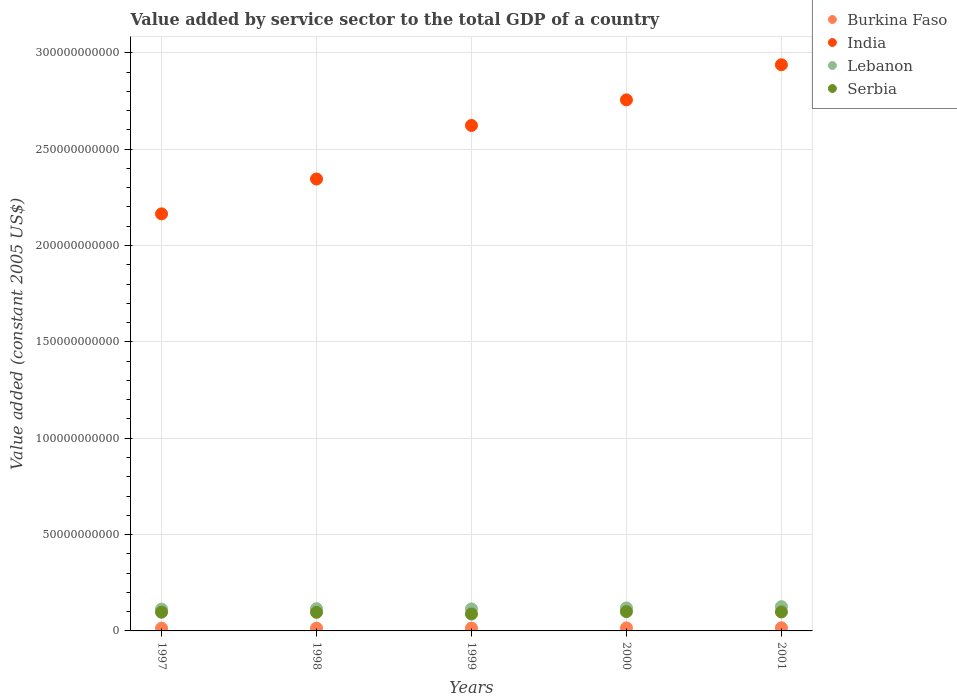How many different coloured dotlines are there?
Offer a very short reply. 4. What is the value added by service sector in Serbia in 1997?
Offer a terse response. 9.73e+09. Across all years, what is the maximum value added by service sector in Burkina Faso?
Ensure brevity in your answer.  1.62e+09. Across all years, what is the minimum value added by service sector in Burkina Faso?
Give a very brief answer. 1.40e+09. In which year was the value added by service sector in Lebanon minimum?
Your answer should be compact. 1997. What is the total value added by service sector in India in the graph?
Make the answer very short. 1.28e+12. What is the difference between the value added by service sector in India in 1999 and that in 2001?
Keep it short and to the point. -3.15e+1. What is the difference between the value added by service sector in Lebanon in 1999 and the value added by service sector in India in 2001?
Ensure brevity in your answer.  -2.82e+11. What is the average value added by service sector in India per year?
Your response must be concise. 2.57e+11. In the year 1999, what is the difference between the value added by service sector in Burkina Faso and value added by service sector in India?
Make the answer very short. -2.61e+11. What is the ratio of the value added by service sector in India in 1998 to that in 2001?
Make the answer very short. 0.8. Is the value added by service sector in Burkina Faso in 2000 less than that in 2001?
Offer a very short reply. Yes. Is the difference between the value added by service sector in Burkina Faso in 1998 and 1999 greater than the difference between the value added by service sector in India in 1998 and 1999?
Make the answer very short. Yes. What is the difference between the highest and the second highest value added by service sector in Burkina Faso?
Your response must be concise. 5.86e+07. What is the difference between the highest and the lowest value added by service sector in India?
Ensure brevity in your answer.  7.74e+1. In how many years, is the value added by service sector in India greater than the average value added by service sector in India taken over all years?
Ensure brevity in your answer.  3. Is the sum of the value added by service sector in India in 1997 and 2000 greater than the maximum value added by service sector in Lebanon across all years?
Keep it short and to the point. Yes. Is it the case that in every year, the sum of the value added by service sector in Burkina Faso and value added by service sector in Lebanon  is greater than the value added by service sector in India?
Your response must be concise. No. Does the value added by service sector in Burkina Faso monotonically increase over the years?
Provide a succinct answer. No. Is the value added by service sector in Burkina Faso strictly greater than the value added by service sector in Serbia over the years?
Offer a very short reply. No. Is the value added by service sector in Burkina Faso strictly less than the value added by service sector in India over the years?
Your response must be concise. Yes. Are the values on the major ticks of Y-axis written in scientific E-notation?
Make the answer very short. No. Does the graph contain any zero values?
Make the answer very short. No. How many legend labels are there?
Offer a terse response. 4. How are the legend labels stacked?
Your answer should be compact. Vertical. What is the title of the graph?
Provide a short and direct response. Value added by service sector to the total GDP of a country. What is the label or title of the X-axis?
Ensure brevity in your answer.  Years. What is the label or title of the Y-axis?
Your response must be concise. Value added (constant 2005 US$). What is the Value added (constant 2005 US$) in Burkina Faso in 1997?
Ensure brevity in your answer.  1.40e+09. What is the Value added (constant 2005 US$) of India in 1997?
Offer a terse response. 2.16e+11. What is the Value added (constant 2005 US$) of Lebanon in 1997?
Make the answer very short. 1.13e+1. What is the Value added (constant 2005 US$) in Serbia in 1997?
Make the answer very short. 9.73e+09. What is the Value added (constant 2005 US$) in Burkina Faso in 1998?
Offer a very short reply. 1.44e+09. What is the Value added (constant 2005 US$) in India in 1998?
Provide a succinct answer. 2.35e+11. What is the Value added (constant 2005 US$) of Lebanon in 1998?
Make the answer very short. 1.15e+1. What is the Value added (constant 2005 US$) of Serbia in 1998?
Provide a succinct answer. 9.64e+09. What is the Value added (constant 2005 US$) in Burkina Faso in 1999?
Provide a short and direct response. 1.44e+09. What is the Value added (constant 2005 US$) in India in 1999?
Make the answer very short. 2.62e+11. What is the Value added (constant 2005 US$) of Lebanon in 1999?
Your answer should be very brief. 1.14e+1. What is the Value added (constant 2005 US$) of Serbia in 1999?
Provide a short and direct response. 8.80e+09. What is the Value added (constant 2005 US$) of Burkina Faso in 2000?
Ensure brevity in your answer.  1.56e+09. What is the Value added (constant 2005 US$) in India in 2000?
Your response must be concise. 2.76e+11. What is the Value added (constant 2005 US$) in Lebanon in 2000?
Ensure brevity in your answer.  1.19e+1. What is the Value added (constant 2005 US$) of Serbia in 2000?
Ensure brevity in your answer.  1.00e+1. What is the Value added (constant 2005 US$) of Burkina Faso in 2001?
Make the answer very short. 1.62e+09. What is the Value added (constant 2005 US$) in India in 2001?
Your response must be concise. 2.94e+11. What is the Value added (constant 2005 US$) in Lebanon in 2001?
Offer a terse response. 1.26e+1. What is the Value added (constant 2005 US$) in Serbia in 2001?
Provide a short and direct response. 9.84e+09. Across all years, what is the maximum Value added (constant 2005 US$) of Burkina Faso?
Your answer should be compact. 1.62e+09. Across all years, what is the maximum Value added (constant 2005 US$) in India?
Provide a short and direct response. 2.94e+11. Across all years, what is the maximum Value added (constant 2005 US$) in Lebanon?
Make the answer very short. 1.26e+1. Across all years, what is the maximum Value added (constant 2005 US$) of Serbia?
Ensure brevity in your answer.  1.00e+1. Across all years, what is the minimum Value added (constant 2005 US$) of Burkina Faso?
Offer a very short reply. 1.40e+09. Across all years, what is the minimum Value added (constant 2005 US$) in India?
Keep it short and to the point. 2.16e+11. Across all years, what is the minimum Value added (constant 2005 US$) in Lebanon?
Make the answer very short. 1.13e+1. Across all years, what is the minimum Value added (constant 2005 US$) in Serbia?
Provide a succinct answer. 8.80e+09. What is the total Value added (constant 2005 US$) of Burkina Faso in the graph?
Provide a succinct answer. 7.47e+09. What is the total Value added (constant 2005 US$) in India in the graph?
Provide a succinct answer. 1.28e+12. What is the total Value added (constant 2005 US$) of Lebanon in the graph?
Make the answer very short. 5.88e+1. What is the total Value added (constant 2005 US$) of Serbia in the graph?
Provide a succinct answer. 4.80e+1. What is the difference between the Value added (constant 2005 US$) in Burkina Faso in 1997 and that in 1998?
Ensure brevity in your answer.  -4.05e+07. What is the difference between the Value added (constant 2005 US$) in India in 1997 and that in 1998?
Provide a succinct answer. -1.81e+1. What is the difference between the Value added (constant 2005 US$) in Lebanon in 1997 and that in 1998?
Ensure brevity in your answer.  -1.89e+08. What is the difference between the Value added (constant 2005 US$) of Serbia in 1997 and that in 1998?
Your response must be concise. 8.61e+07. What is the difference between the Value added (constant 2005 US$) in Burkina Faso in 1997 and that in 1999?
Make the answer very short. -3.97e+07. What is the difference between the Value added (constant 2005 US$) in India in 1997 and that in 1999?
Provide a succinct answer. -4.59e+1. What is the difference between the Value added (constant 2005 US$) in Lebanon in 1997 and that in 1999?
Make the answer very short. -1.01e+08. What is the difference between the Value added (constant 2005 US$) of Serbia in 1997 and that in 1999?
Your response must be concise. 9.27e+08. What is the difference between the Value added (constant 2005 US$) of Burkina Faso in 1997 and that in 2000?
Ensure brevity in your answer.  -1.62e+08. What is the difference between the Value added (constant 2005 US$) of India in 1997 and that in 2000?
Your response must be concise. -5.92e+1. What is the difference between the Value added (constant 2005 US$) of Lebanon in 1997 and that in 2000?
Give a very brief answer. -6.04e+08. What is the difference between the Value added (constant 2005 US$) in Serbia in 1997 and that in 2000?
Your answer should be very brief. -2.72e+08. What is the difference between the Value added (constant 2005 US$) in Burkina Faso in 1997 and that in 2001?
Your response must be concise. -2.21e+08. What is the difference between the Value added (constant 2005 US$) in India in 1997 and that in 2001?
Give a very brief answer. -7.74e+1. What is the difference between the Value added (constant 2005 US$) of Lebanon in 1997 and that in 2001?
Your answer should be compact. -1.26e+09. What is the difference between the Value added (constant 2005 US$) in Serbia in 1997 and that in 2001?
Your answer should be compact. -1.15e+08. What is the difference between the Value added (constant 2005 US$) in Burkina Faso in 1998 and that in 1999?
Your response must be concise. 8.60e+05. What is the difference between the Value added (constant 2005 US$) of India in 1998 and that in 1999?
Your answer should be compact. -2.78e+1. What is the difference between the Value added (constant 2005 US$) in Lebanon in 1998 and that in 1999?
Offer a very short reply. 8.77e+07. What is the difference between the Value added (constant 2005 US$) in Serbia in 1998 and that in 1999?
Your answer should be compact. 8.41e+08. What is the difference between the Value added (constant 2005 US$) of Burkina Faso in 1998 and that in 2000?
Provide a short and direct response. -1.22e+08. What is the difference between the Value added (constant 2005 US$) in India in 1998 and that in 2000?
Offer a very short reply. -4.11e+1. What is the difference between the Value added (constant 2005 US$) of Lebanon in 1998 and that in 2000?
Your answer should be very brief. -4.15e+08. What is the difference between the Value added (constant 2005 US$) of Serbia in 1998 and that in 2000?
Your response must be concise. -3.58e+08. What is the difference between the Value added (constant 2005 US$) of Burkina Faso in 1998 and that in 2001?
Provide a succinct answer. -1.80e+08. What is the difference between the Value added (constant 2005 US$) of India in 1998 and that in 2001?
Your answer should be compact. -5.93e+1. What is the difference between the Value added (constant 2005 US$) in Lebanon in 1998 and that in 2001?
Offer a very short reply. -1.07e+09. What is the difference between the Value added (constant 2005 US$) in Serbia in 1998 and that in 2001?
Give a very brief answer. -2.01e+08. What is the difference between the Value added (constant 2005 US$) in Burkina Faso in 1999 and that in 2000?
Offer a terse response. -1.23e+08. What is the difference between the Value added (constant 2005 US$) in India in 1999 and that in 2000?
Ensure brevity in your answer.  -1.33e+1. What is the difference between the Value added (constant 2005 US$) of Lebanon in 1999 and that in 2000?
Ensure brevity in your answer.  -5.03e+08. What is the difference between the Value added (constant 2005 US$) of Serbia in 1999 and that in 2000?
Ensure brevity in your answer.  -1.20e+09. What is the difference between the Value added (constant 2005 US$) in Burkina Faso in 1999 and that in 2001?
Keep it short and to the point. -1.81e+08. What is the difference between the Value added (constant 2005 US$) in India in 1999 and that in 2001?
Provide a short and direct response. -3.15e+1. What is the difference between the Value added (constant 2005 US$) in Lebanon in 1999 and that in 2001?
Offer a terse response. -1.16e+09. What is the difference between the Value added (constant 2005 US$) of Serbia in 1999 and that in 2001?
Ensure brevity in your answer.  -1.04e+09. What is the difference between the Value added (constant 2005 US$) in Burkina Faso in 2000 and that in 2001?
Keep it short and to the point. -5.86e+07. What is the difference between the Value added (constant 2005 US$) of India in 2000 and that in 2001?
Offer a terse response. -1.82e+1. What is the difference between the Value added (constant 2005 US$) in Lebanon in 2000 and that in 2001?
Give a very brief answer. -6.55e+08. What is the difference between the Value added (constant 2005 US$) in Serbia in 2000 and that in 2001?
Ensure brevity in your answer.  1.57e+08. What is the difference between the Value added (constant 2005 US$) in Burkina Faso in 1997 and the Value added (constant 2005 US$) in India in 1998?
Keep it short and to the point. -2.33e+11. What is the difference between the Value added (constant 2005 US$) of Burkina Faso in 1997 and the Value added (constant 2005 US$) of Lebanon in 1998?
Provide a succinct answer. -1.01e+1. What is the difference between the Value added (constant 2005 US$) in Burkina Faso in 1997 and the Value added (constant 2005 US$) in Serbia in 1998?
Make the answer very short. -8.24e+09. What is the difference between the Value added (constant 2005 US$) in India in 1997 and the Value added (constant 2005 US$) in Lebanon in 1998?
Make the answer very short. 2.05e+11. What is the difference between the Value added (constant 2005 US$) in India in 1997 and the Value added (constant 2005 US$) in Serbia in 1998?
Offer a very short reply. 2.07e+11. What is the difference between the Value added (constant 2005 US$) of Lebanon in 1997 and the Value added (constant 2005 US$) of Serbia in 1998?
Keep it short and to the point. 1.70e+09. What is the difference between the Value added (constant 2005 US$) of Burkina Faso in 1997 and the Value added (constant 2005 US$) of India in 1999?
Keep it short and to the point. -2.61e+11. What is the difference between the Value added (constant 2005 US$) in Burkina Faso in 1997 and the Value added (constant 2005 US$) in Lebanon in 1999?
Provide a short and direct response. -1.00e+1. What is the difference between the Value added (constant 2005 US$) in Burkina Faso in 1997 and the Value added (constant 2005 US$) in Serbia in 1999?
Provide a short and direct response. -7.40e+09. What is the difference between the Value added (constant 2005 US$) in India in 1997 and the Value added (constant 2005 US$) in Lebanon in 1999?
Provide a short and direct response. 2.05e+11. What is the difference between the Value added (constant 2005 US$) in India in 1997 and the Value added (constant 2005 US$) in Serbia in 1999?
Offer a terse response. 2.08e+11. What is the difference between the Value added (constant 2005 US$) of Lebanon in 1997 and the Value added (constant 2005 US$) of Serbia in 1999?
Make the answer very short. 2.54e+09. What is the difference between the Value added (constant 2005 US$) in Burkina Faso in 1997 and the Value added (constant 2005 US$) in India in 2000?
Offer a terse response. -2.74e+11. What is the difference between the Value added (constant 2005 US$) of Burkina Faso in 1997 and the Value added (constant 2005 US$) of Lebanon in 2000?
Offer a terse response. -1.05e+1. What is the difference between the Value added (constant 2005 US$) of Burkina Faso in 1997 and the Value added (constant 2005 US$) of Serbia in 2000?
Provide a short and direct response. -8.60e+09. What is the difference between the Value added (constant 2005 US$) in India in 1997 and the Value added (constant 2005 US$) in Lebanon in 2000?
Provide a short and direct response. 2.04e+11. What is the difference between the Value added (constant 2005 US$) of India in 1997 and the Value added (constant 2005 US$) of Serbia in 2000?
Your answer should be very brief. 2.06e+11. What is the difference between the Value added (constant 2005 US$) in Lebanon in 1997 and the Value added (constant 2005 US$) in Serbia in 2000?
Make the answer very short. 1.34e+09. What is the difference between the Value added (constant 2005 US$) in Burkina Faso in 1997 and the Value added (constant 2005 US$) in India in 2001?
Give a very brief answer. -2.92e+11. What is the difference between the Value added (constant 2005 US$) in Burkina Faso in 1997 and the Value added (constant 2005 US$) in Lebanon in 2001?
Give a very brief answer. -1.12e+1. What is the difference between the Value added (constant 2005 US$) of Burkina Faso in 1997 and the Value added (constant 2005 US$) of Serbia in 2001?
Give a very brief answer. -8.44e+09. What is the difference between the Value added (constant 2005 US$) of India in 1997 and the Value added (constant 2005 US$) of Lebanon in 2001?
Offer a terse response. 2.04e+11. What is the difference between the Value added (constant 2005 US$) of India in 1997 and the Value added (constant 2005 US$) of Serbia in 2001?
Give a very brief answer. 2.07e+11. What is the difference between the Value added (constant 2005 US$) in Lebanon in 1997 and the Value added (constant 2005 US$) in Serbia in 2001?
Provide a succinct answer. 1.49e+09. What is the difference between the Value added (constant 2005 US$) of Burkina Faso in 1998 and the Value added (constant 2005 US$) of India in 1999?
Your response must be concise. -2.61e+11. What is the difference between the Value added (constant 2005 US$) of Burkina Faso in 1998 and the Value added (constant 2005 US$) of Lebanon in 1999?
Ensure brevity in your answer.  -1.00e+1. What is the difference between the Value added (constant 2005 US$) of Burkina Faso in 1998 and the Value added (constant 2005 US$) of Serbia in 1999?
Give a very brief answer. -7.36e+09. What is the difference between the Value added (constant 2005 US$) of India in 1998 and the Value added (constant 2005 US$) of Lebanon in 1999?
Make the answer very short. 2.23e+11. What is the difference between the Value added (constant 2005 US$) of India in 1998 and the Value added (constant 2005 US$) of Serbia in 1999?
Offer a terse response. 2.26e+11. What is the difference between the Value added (constant 2005 US$) of Lebanon in 1998 and the Value added (constant 2005 US$) of Serbia in 1999?
Provide a succinct answer. 2.73e+09. What is the difference between the Value added (constant 2005 US$) in Burkina Faso in 1998 and the Value added (constant 2005 US$) in India in 2000?
Offer a very short reply. -2.74e+11. What is the difference between the Value added (constant 2005 US$) of Burkina Faso in 1998 and the Value added (constant 2005 US$) of Lebanon in 2000?
Provide a succinct answer. -1.05e+1. What is the difference between the Value added (constant 2005 US$) of Burkina Faso in 1998 and the Value added (constant 2005 US$) of Serbia in 2000?
Your response must be concise. -8.56e+09. What is the difference between the Value added (constant 2005 US$) of India in 1998 and the Value added (constant 2005 US$) of Lebanon in 2000?
Make the answer very short. 2.23e+11. What is the difference between the Value added (constant 2005 US$) of India in 1998 and the Value added (constant 2005 US$) of Serbia in 2000?
Provide a succinct answer. 2.25e+11. What is the difference between the Value added (constant 2005 US$) in Lebanon in 1998 and the Value added (constant 2005 US$) in Serbia in 2000?
Provide a succinct answer. 1.53e+09. What is the difference between the Value added (constant 2005 US$) in Burkina Faso in 1998 and the Value added (constant 2005 US$) in India in 2001?
Make the answer very short. -2.92e+11. What is the difference between the Value added (constant 2005 US$) in Burkina Faso in 1998 and the Value added (constant 2005 US$) in Lebanon in 2001?
Keep it short and to the point. -1.12e+1. What is the difference between the Value added (constant 2005 US$) in Burkina Faso in 1998 and the Value added (constant 2005 US$) in Serbia in 2001?
Your response must be concise. -8.40e+09. What is the difference between the Value added (constant 2005 US$) in India in 1998 and the Value added (constant 2005 US$) in Lebanon in 2001?
Provide a succinct answer. 2.22e+11. What is the difference between the Value added (constant 2005 US$) of India in 1998 and the Value added (constant 2005 US$) of Serbia in 2001?
Provide a short and direct response. 2.25e+11. What is the difference between the Value added (constant 2005 US$) in Lebanon in 1998 and the Value added (constant 2005 US$) in Serbia in 2001?
Offer a terse response. 1.68e+09. What is the difference between the Value added (constant 2005 US$) in Burkina Faso in 1999 and the Value added (constant 2005 US$) in India in 2000?
Offer a very short reply. -2.74e+11. What is the difference between the Value added (constant 2005 US$) in Burkina Faso in 1999 and the Value added (constant 2005 US$) in Lebanon in 2000?
Your answer should be compact. -1.05e+1. What is the difference between the Value added (constant 2005 US$) in Burkina Faso in 1999 and the Value added (constant 2005 US$) in Serbia in 2000?
Keep it short and to the point. -8.56e+09. What is the difference between the Value added (constant 2005 US$) in India in 1999 and the Value added (constant 2005 US$) in Lebanon in 2000?
Your response must be concise. 2.50e+11. What is the difference between the Value added (constant 2005 US$) of India in 1999 and the Value added (constant 2005 US$) of Serbia in 2000?
Give a very brief answer. 2.52e+11. What is the difference between the Value added (constant 2005 US$) of Lebanon in 1999 and the Value added (constant 2005 US$) of Serbia in 2000?
Give a very brief answer. 1.44e+09. What is the difference between the Value added (constant 2005 US$) of Burkina Faso in 1999 and the Value added (constant 2005 US$) of India in 2001?
Offer a very short reply. -2.92e+11. What is the difference between the Value added (constant 2005 US$) of Burkina Faso in 1999 and the Value added (constant 2005 US$) of Lebanon in 2001?
Provide a succinct answer. -1.12e+1. What is the difference between the Value added (constant 2005 US$) in Burkina Faso in 1999 and the Value added (constant 2005 US$) in Serbia in 2001?
Your response must be concise. -8.40e+09. What is the difference between the Value added (constant 2005 US$) of India in 1999 and the Value added (constant 2005 US$) of Lebanon in 2001?
Provide a short and direct response. 2.50e+11. What is the difference between the Value added (constant 2005 US$) in India in 1999 and the Value added (constant 2005 US$) in Serbia in 2001?
Ensure brevity in your answer.  2.52e+11. What is the difference between the Value added (constant 2005 US$) in Lebanon in 1999 and the Value added (constant 2005 US$) in Serbia in 2001?
Provide a succinct answer. 1.60e+09. What is the difference between the Value added (constant 2005 US$) of Burkina Faso in 2000 and the Value added (constant 2005 US$) of India in 2001?
Provide a short and direct response. -2.92e+11. What is the difference between the Value added (constant 2005 US$) in Burkina Faso in 2000 and the Value added (constant 2005 US$) in Lebanon in 2001?
Your answer should be compact. -1.10e+1. What is the difference between the Value added (constant 2005 US$) in Burkina Faso in 2000 and the Value added (constant 2005 US$) in Serbia in 2001?
Your answer should be compact. -8.28e+09. What is the difference between the Value added (constant 2005 US$) of India in 2000 and the Value added (constant 2005 US$) of Lebanon in 2001?
Your response must be concise. 2.63e+11. What is the difference between the Value added (constant 2005 US$) of India in 2000 and the Value added (constant 2005 US$) of Serbia in 2001?
Your answer should be very brief. 2.66e+11. What is the difference between the Value added (constant 2005 US$) in Lebanon in 2000 and the Value added (constant 2005 US$) in Serbia in 2001?
Your answer should be compact. 2.10e+09. What is the average Value added (constant 2005 US$) in Burkina Faso per year?
Give a very brief answer. 1.49e+09. What is the average Value added (constant 2005 US$) in India per year?
Ensure brevity in your answer.  2.57e+11. What is the average Value added (constant 2005 US$) of Lebanon per year?
Give a very brief answer. 1.18e+1. What is the average Value added (constant 2005 US$) in Serbia per year?
Your answer should be compact. 9.60e+09. In the year 1997, what is the difference between the Value added (constant 2005 US$) in Burkina Faso and Value added (constant 2005 US$) in India?
Your response must be concise. -2.15e+11. In the year 1997, what is the difference between the Value added (constant 2005 US$) in Burkina Faso and Value added (constant 2005 US$) in Lebanon?
Make the answer very short. -9.94e+09. In the year 1997, what is the difference between the Value added (constant 2005 US$) of Burkina Faso and Value added (constant 2005 US$) of Serbia?
Keep it short and to the point. -8.33e+09. In the year 1997, what is the difference between the Value added (constant 2005 US$) in India and Value added (constant 2005 US$) in Lebanon?
Your response must be concise. 2.05e+11. In the year 1997, what is the difference between the Value added (constant 2005 US$) of India and Value added (constant 2005 US$) of Serbia?
Make the answer very short. 2.07e+11. In the year 1997, what is the difference between the Value added (constant 2005 US$) of Lebanon and Value added (constant 2005 US$) of Serbia?
Keep it short and to the point. 1.61e+09. In the year 1998, what is the difference between the Value added (constant 2005 US$) of Burkina Faso and Value added (constant 2005 US$) of India?
Give a very brief answer. -2.33e+11. In the year 1998, what is the difference between the Value added (constant 2005 US$) in Burkina Faso and Value added (constant 2005 US$) in Lebanon?
Offer a very short reply. -1.01e+1. In the year 1998, what is the difference between the Value added (constant 2005 US$) in Burkina Faso and Value added (constant 2005 US$) in Serbia?
Provide a short and direct response. -8.20e+09. In the year 1998, what is the difference between the Value added (constant 2005 US$) in India and Value added (constant 2005 US$) in Lebanon?
Ensure brevity in your answer.  2.23e+11. In the year 1998, what is the difference between the Value added (constant 2005 US$) of India and Value added (constant 2005 US$) of Serbia?
Give a very brief answer. 2.25e+11. In the year 1998, what is the difference between the Value added (constant 2005 US$) of Lebanon and Value added (constant 2005 US$) of Serbia?
Make the answer very short. 1.88e+09. In the year 1999, what is the difference between the Value added (constant 2005 US$) in Burkina Faso and Value added (constant 2005 US$) in India?
Ensure brevity in your answer.  -2.61e+11. In the year 1999, what is the difference between the Value added (constant 2005 US$) of Burkina Faso and Value added (constant 2005 US$) of Lebanon?
Your answer should be very brief. -1.00e+1. In the year 1999, what is the difference between the Value added (constant 2005 US$) of Burkina Faso and Value added (constant 2005 US$) of Serbia?
Your response must be concise. -7.36e+09. In the year 1999, what is the difference between the Value added (constant 2005 US$) in India and Value added (constant 2005 US$) in Lebanon?
Provide a short and direct response. 2.51e+11. In the year 1999, what is the difference between the Value added (constant 2005 US$) in India and Value added (constant 2005 US$) in Serbia?
Give a very brief answer. 2.53e+11. In the year 1999, what is the difference between the Value added (constant 2005 US$) of Lebanon and Value added (constant 2005 US$) of Serbia?
Keep it short and to the point. 2.64e+09. In the year 2000, what is the difference between the Value added (constant 2005 US$) in Burkina Faso and Value added (constant 2005 US$) in India?
Your response must be concise. -2.74e+11. In the year 2000, what is the difference between the Value added (constant 2005 US$) in Burkina Faso and Value added (constant 2005 US$) in Lebanon?
Provide a succinct answer. -1.04e+1. In the year 2000, what is the difference between the Value added (constant 2005 US$) in Burkina Faso and Value added (constant 2005 US$) in Serbia?
Your answer should be compact. -8.44e+09. In the year 2000, what is the difference between the Value added (constant 2005 US$) in India and Value added (constant 2005 US$) in Lebanon?
Provide a short and direct response. 2.64e+11. In the year 2000, what is the difference between the Value added (constant 2005 US$) in India and Value added (constant 2005 US$) in Serbia?
Offer a very short reply. 2.66e+11. In the year 2000, what is the difference between the Value added (constant 2005 US$) in Lebanon and Value added (constant 2005 US$) in Serbia?
Ensure brevity in your answer.  1.94e+09. In the year 2001, what is the difference between the Value added (constant 2005 US$) in Burkina Faso and Value added (constant 2005 US$) in India?
Provide a succinct answer. -2.92e+11. In the year 2001, what is the difference between the Value added (constant 2005 US$) in Burkina Faso and Value added (constant 2005 US$) in Lebanon?
Provide a short and direct response. -1.10e+1. In the year 2001, what is the difference between the Value added (constant 2005 US$) in Burkina Faso and Value added (constant 2005 US$) in Serbia?
Your response must be concise. -8.22e+09. In the year 2001, what is the difference between the Value added (constant 2005 US$) in India and Value added (constant 2005 US$) in Lebanon?
Provide a succinct answer. 2.81e+11. In the year 2001, what is the difference between the Value added (constant 2005 US$) of India and Value added (constant 2005 US$) of Serbia?
Your response must be concise. 2.84e+11. In the year 2001, what is the difference between the Value added (constant 2005 US$) in Lebanon and Value added (constant 2005 US$) in Serbia?
Your answer should be compact. 2.75e+09. What is the ratio of the Value added (constant 2005 US$) of Burkina Faso in 1997 to that in 1998?
Your answer should be very brief. 0.97. What is the ratio of the Value added (constant 2005 US$) in India in 1997 to that in 1998?
Provide a short and direct response. 0.92. What is the ratio of the Value added (constant 2005 US$) of Lebanon in 1997 to that in 1998?
Your answer should be compact. 0.98. What is the ratio of the Value added (constant 2005 US$) of Serbia in 1997 to that in 1998?
Keep it short and to the point. 1.01. What is the ratio of the Value added (constant 2005 US$) of Burkina Faso in 1997 to that in 1999?
Your response must be concise. 0.97. What is the ratio of the Value added (constant 2005 US$) of India in 1997 to that in 1999?
Provide a succinct answer. 0.83. What is the ratio of the Value added (constant 2005 US$) in Lebanon in 1997 to that in 1999?
Keep it short and to the point. 0.99. What is the ratio of the Value added (constant 2005 US$) in Serbia in 1997 to that in 1999?
Keep it short and to the point. 1.11. What is the ratio of the Value added (constant 2005 US$) in Burkina Faso in 1997 to that in 2000?
Ensure brevity in your answer.  0.9. What is the ratio of the Value added (constant 2005 US$) in India in 1997 to that in 2000?
Your answer should be compact. 0.79. What is the ratio of the Value added (constant 2005 US$) in Lebanon in 1997 to that in 2000?
Your response must be concise. 0.95. What is the ratio of the Value added (constant 2005 US$) in Serbia in 1997 to that in 2000?
Offer a terse response. 0.97. What is the ratio of the Value added (constant 2005 US$) of Burkina Faso in 1997 to that in 2001?
Offer a terse response. 0.86. What is the ratio of the Value added (constant 2005 US$) of India in 1997 to that in 2001?
Offer a very short reply. 0.74. What is the ratio of the Value added (constant 2005 US$) in Lebanon in 1997 to that in 2001?
Your answer should be very brief. 0.9. What is the ratio of the Value added (constant 2005 US$) of Serbia in 1997 to that in 2001?
Your answer should be compact. 0.99. What is the ratio of the Value added (constant 2005 US$) in India in 1998 to that in 1999?
Ensure brevity in your answer.  0.89. What is the ratio of the Value added (constant 2005 US$) in Lebanon in 1998 to that in 1999?
Your response must be concise. 1.01. What is the ratio of the Value added (constant 2005 US$) in Serbia in 1998 to that in 1999?
Your answer should be very brief. 1.1. What is the ratio of the Value added (constant 2005 US$) in Burkina Faso in 1998 to that in 2000?
Make the answer very short. 0.92. What is the ratio of the Value added (constant 2005 US$) of India in 1998 to that in 2000?
Your answer should be compact. 0.85. What is the ratio of the Value added (constant 2005 US$) of Lebanon in 1998 to that in 2000?
Your response must be concise. 0.97. What is the ratio of the Value added (constant 2005 US$) in Serbia in 1998 to that in 2000?
Provide a short and direct response. 0.96. What is the ratio of the Value added (constant 2005 US$) in Burkina Faso in 1998 to that in 2001?
Give a very brief answer. 0.89. What is the ratio of the Value added (constant 2005 US$) of India in 1998 to that in 2001?
Keep it short and to the point. 0.8. What is the ratio of the Value added (constant 2005 US$) of Lebanon in 1998 to that in 2001?
Provide a succinct answer. 0.92. What is the ratio of the Value added (constant 2005 US$) in Serbia in 1998 to that in 2001?
Keep it short and to the point. 0.98. What is the ratio of the Value added (constant 2005 US$) in Burkina Faso in 1999 to that in 2000?
Provide a succinct answer. 0.92. What is the ratio of the Value added (constant 2005 US$) in India in 1999 to that in 2000?
Offer a very short reply. 0.95. What is the ratio of the Value added (constant 2005 US$) of Lebanon in 1999 to that in 2000?
Make the answer very short. 0.96. What is the ratio of the Value added (constant 2005 US$) of Serbia in 1999 to that in 2000?
Make the answer very short. 0.88. What is the ratio of the Value added (constant 2005 US$) in Burkina Faso in 1999 to that in 2001?
Make the answer very short. 0.89. What is the ratio of the Value added (constant 2005 US$) of India in 1999 to that in 2001?
Your response must be concise. 0.89. What is the ratio of the Value added (constant 2005 US$) in Lebanon in 1999 to that in 2001?
Offer a very short reply. 0.91. What is the ratio of the Value added (constant 2005 US$) in Serbia in 1999 to that in 2001?
Keep it short and to the point. 0.89. What is the ratio of the Value added (constant 2005 US$) of Burkina Faso in 2000 to that in 2001?
Provide a short and direct response. 0.96. What is the ratio of the Value added (constant 2005 US$) in India in 2000 to that in 2001?
Offer a very short reply. 0.94. What is the ratio of the Value added (constant 2005 US$) in Lebanon in 2000 to that in 2001?
Offer a terse response. 0.95. What is the ratio of the Value added (constant 2005 US$) of Serbia in 2000 to that in 2001?
Offer a terse response. 1.02. What is the difference between the highest and the second highest Value added (constant 2005 US$) of Burkina Faso?
Offer a very short reply. 5.86e+07. What is the difference between the highest and the second highest Value added (constant 2005 US$) in India?
Your response must be concise. 1.82e+1. What is the difference between the highest and the second highest Value added (constant 2005 US$) of Lebanon?
Offer a terse response. 6.55e+08. What is the difference between the highest and the second highest Value added (constant 2005 US$) in Serbia?
Your answer should be compact. 1.57e+08. What is the difference between the highest and the lowest Value added (constant 2005 US$) of Burkina Faso?
Offer a very short reply. 2.21e+08. What is the difference between the highest and the lowest Value added (constant 2005 US$) of India?
Offer a terse response. 7.74e+1. What is the difference between the highest and the lowest Value added (constant 2005 US$) in Lebanon?
Your answer should be very brief. 1.26e+09. What is the difference between the highest and the lowest Value added (constant 2005 US$) of Serbia?
Offer a very short reply. 1.20e+09. 